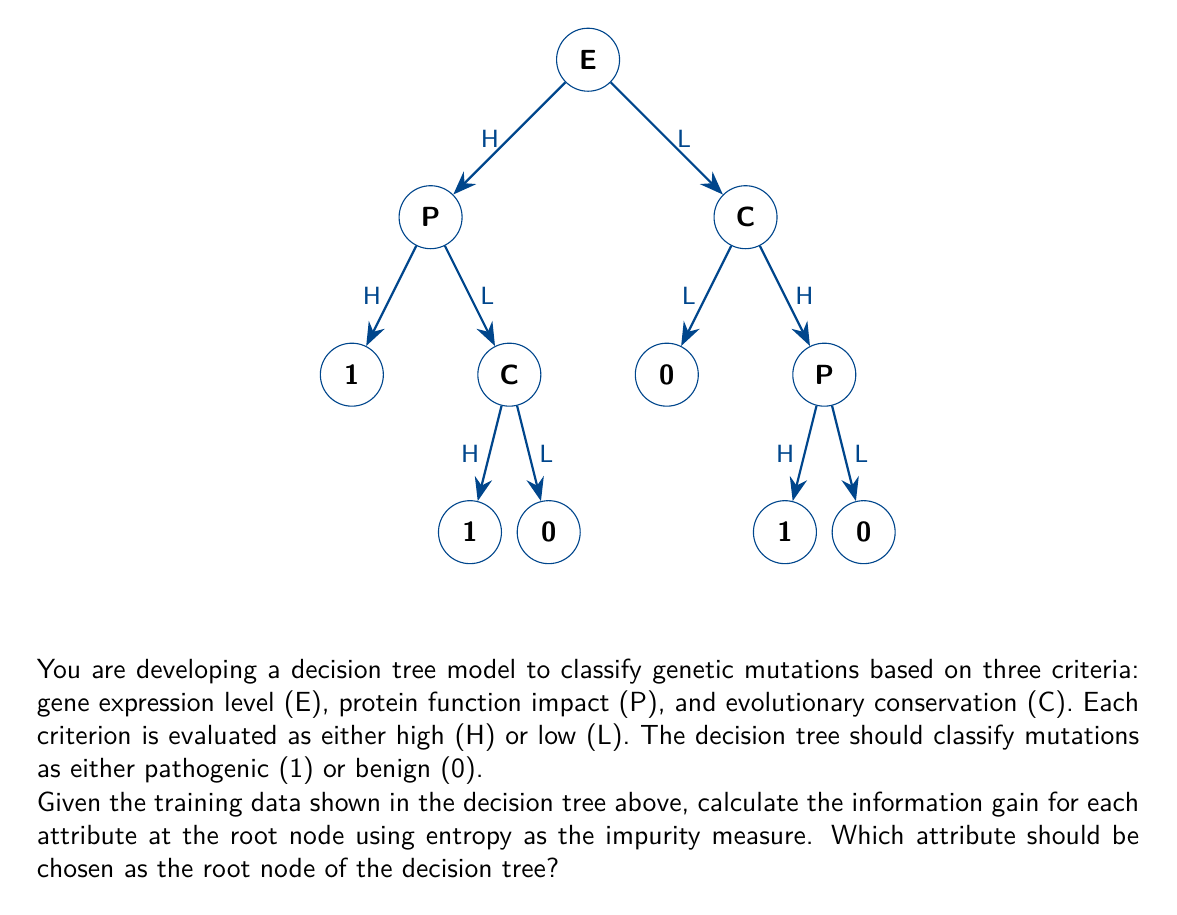Help me with this question. To determine the best attribute for the root node, we need to calculate the information gain for each attribute. The attribute with the highest information gain will be chosen as the root node.

Step 1: Calculate the entropy of the entire dataset.
Total samples: 8
Pathogenic (1): 5
Benign (0): 3

$H(S) = -\frac{5}{8}\log_2(\frac{5}{8}) - \frac{3}{8}\log_2(\frac{3}{8}) = 0.9544$ bits

Step 2: Calculate the information gain for each attribute.

For Gene Expression (E):
$H(S|E=H) = -\frac{3}{4}\log_2(\frac{3}{4}) - \frac{1}{4}\log_2(\frac{1}{4}) = 0.8113$ bits
$H(S|E=L) = -\frac{1}{2}\log_2(\frac{1}{2}) - \frac{1}{2}\log_2(\frac{1}{2}) = 1$ bit
$IG(S,E) = H(S) - (\frac{4}{8}H(S|E=H) + \frac{4}{8}H(S|E=L)) = 0.9544 - 0.9056 = 0.0488$ bits

For Protein Function (P):
$H(S|P=H) = -\frac{4}{4}\log_2(\frac{4}{4}) - \frac{0}{4}\log_2(\frac{0}{4}) = 0$ bits
$H(S|P=L) = -\frac{1}{4}\log_2(\frac{1}{4}) - \frac{3}{4}\log_2(\frac{3}{4}) = 0.8113$ bits
$IG(S,P) = H(S) - (\frac{4}{8}H(S|P=H) + \frac{4}{8}H(S|P=L)) = 0.9544 - 0.4056 = 0.5488$ bits

For Conservation (C):
$H(S|C=H) = -\frac{3}{4}\log_2(\frac{3}{4}) - \frac{1}{4}\log_2(\frac{1}{4}) = 0.8113$ bits
$H(S|C=L) = -\frac{1}{2}\log_2(\frac{1}{2}) - \frac{1}{2}\log_2(\frac{1}{2}) = 1$ bit
$IG(S,C) = H(S) - (\frac{4}{8}H(S|C=H) + \frac{4}{8}H(S|C=L)) = 0.9544 - 0.9056 = 0.0488$ bits

Step 3: Compare the information gains.
E: 0.0488 bits
P: 0.5488 bits
C: 0.0488 bits

The attribute with the highest information gain is Protein Function (P) with 0.5488 bits.
Answer: Protein Function (P) 